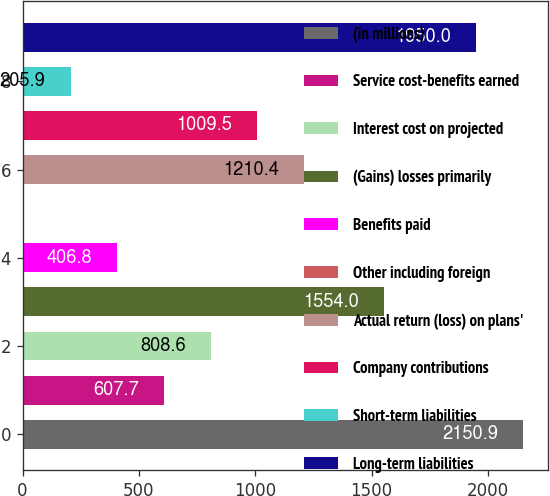<chart> <loc_0><loc_0><loc_500><loc_500><bar_chart><fcel>(in millions)<fcel>Service cost-benefits earned<fcel>Interest cost on projected<fcel>(Gains) losses primarily<fcel>Benefits paid<fcel>Other including foreign<fcel>Actual return (loss) on plans'<fcel>Company contributions<fcel>Short-term liabilities<fcel>Long-term liabilities<nl><fcel>2150.9<fcel>607.7<fcel>808.6<fcel>1554<fcel>406.8<fcel>5<fcel>1210.4<fcel>1009.5<fcel>205.9<fcel>1950<nl></chart> 